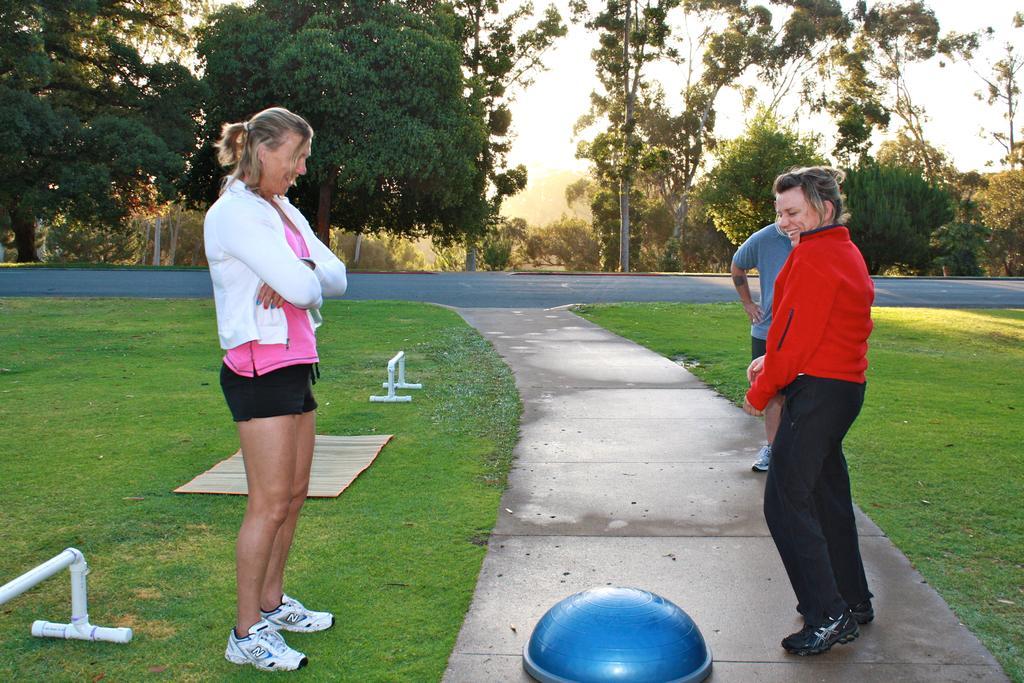In one or two sentences, can you explain what this image depicts? In this picture I can see people standing on the ground. In the background I can see trees and sky. Here I can see some objects, a road and grass. 